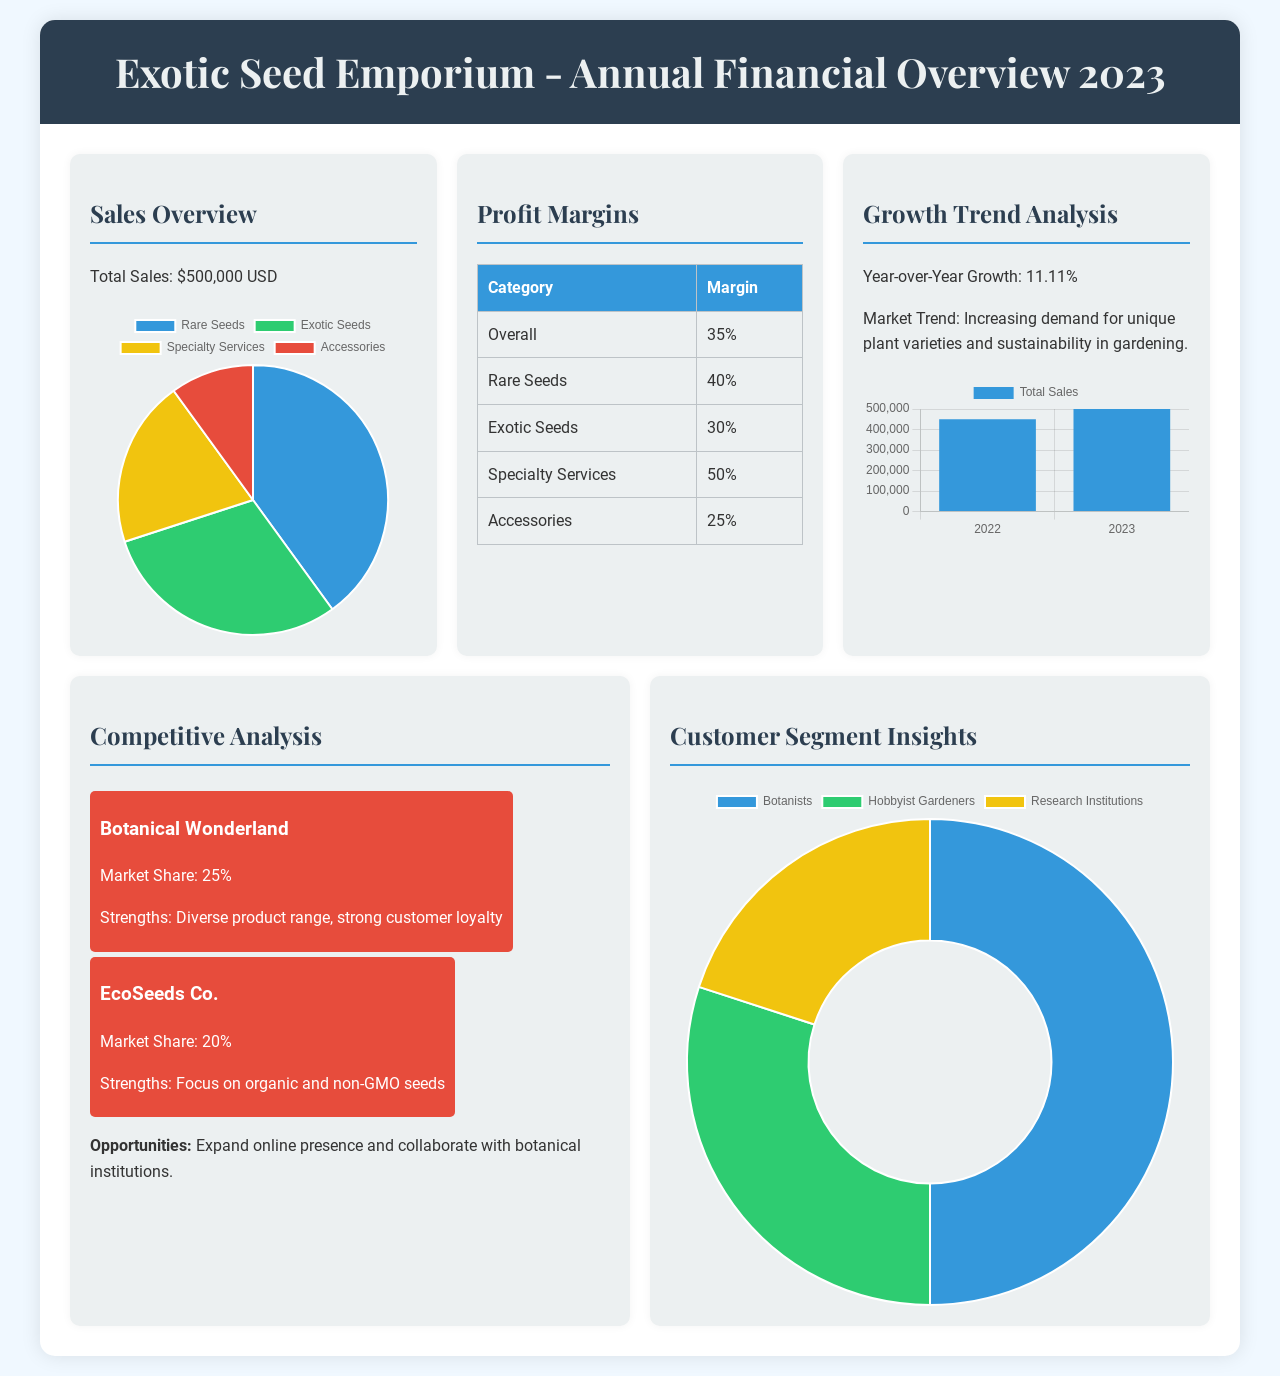What was the total sales amount? The total sales amount is stated as $500,000 USD in the document.
Answer: $500,000 USD What is the profit margin for rare seeds? The document lists the profit margin for rare seeds as 40%.
Answer: 40% What is the year-over-year growth percentage? The document provides a year-over-year growth figure of 11.11%.
Answer: 11.11% Which category has the highest profit margin? The category with the highest profit margin mentioned is Specialty Services at 50%.
Answer: 50% What is the market share of Botanical Wonderland? The document indicates that Botanical Wonderland has a market share of 25%.
Answer: 25% What percentage of sales are from hobbyist gardeners? The document states that hobbyist gardeners comprise 30% of the customer segments.
Answer: 30% What is the primary trend mentioned in Growth Trend Analysis? The document highlights "Increasing demand for unique plant varieties and sustainability in gardening" as the primary trend.
Answer: Increasing demand for unique plant varieties and sustainability in gardening Which competitor focuses on organic seeds? According to the document, EcoSeeds Co. focuses on organic and non-GMO seeds.
Answer: EcoSeeds Co 